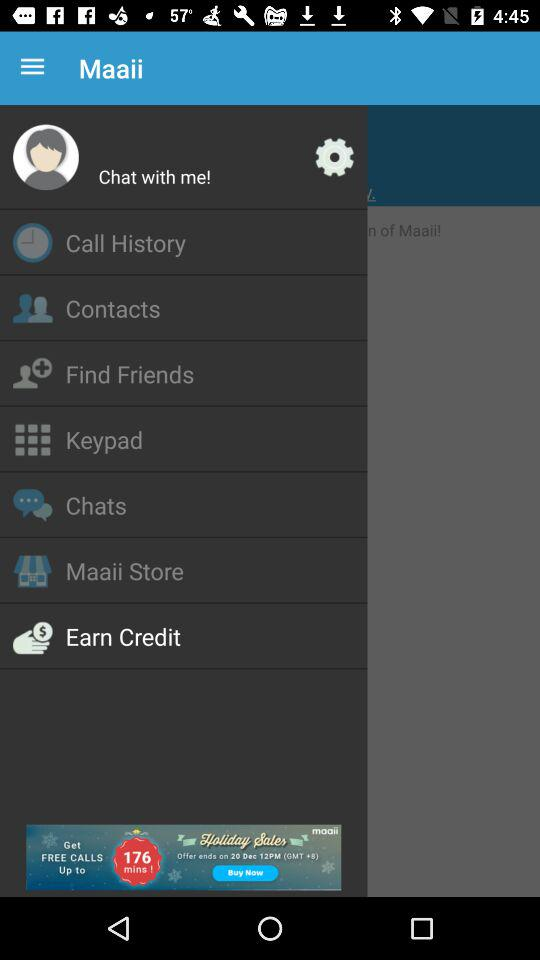Which option is selected in the list? The selected option is "Earn Credit". 